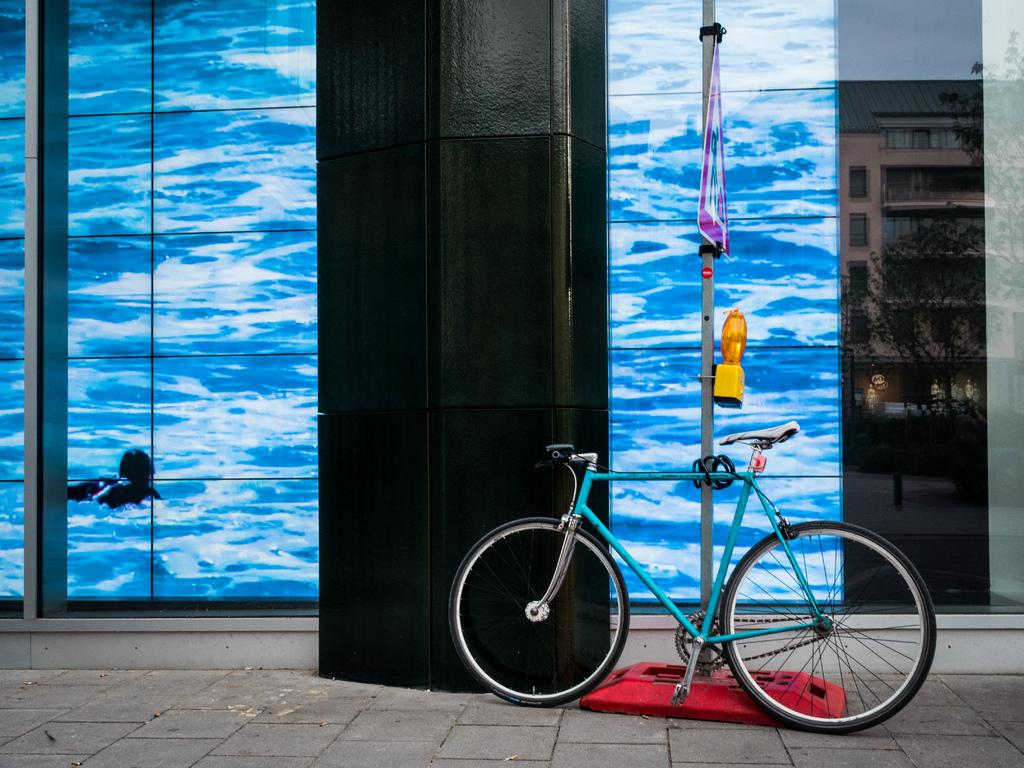What is parked in the image? There is a bicycle parked in the image. What can be seen attached to a pole in the image? There is a flag in the image. What is the pole used for in the image? The pole is used to hold the flag in the image. What type of structure is visible in the image? There is a building with windows in the image. What type of vegetation is present in the image? There are trees in the image. What part of the natural environment is visible in the image? The sky is visible in the image. What type of home does the laborer live in, as seen in the image? There is no information about a laborer or a home in the image. The image features a parked bicycle, a flag, a pole, a screen, a building with windows, trees, and the sky. 